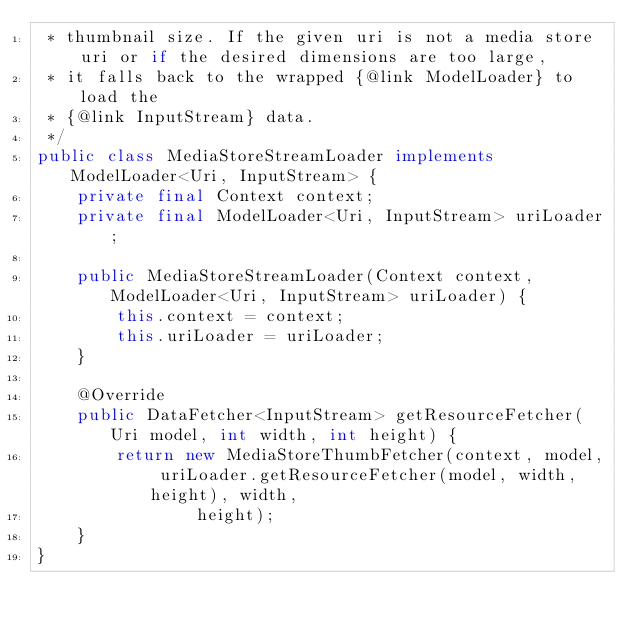<code> <loc_0><loc_0><loc_500><loc_500><_Java_> * thumbnail size. If the given uri is not a media store uri or if the desired dimensions are too large,
 * it falls back to the wrapped {@link ModelLoader} to load the
 * {@link InputStream} data.
 */
public class MediaStoreStreamLoader implements ModelLoader<Uri, InputStream> {
    private final Context context;
    private final ModelLoader<Uri, InputStream> uriLoader;

    public MediaStoreStreamLoader(Context context, ModelLoader<Uri, InputStream> uriLoader) {
        this.context = context;
        this.uriLoader = uriLoader;
    }

    @Override
    public DataFetcher<InputStream> getResourceFetcher(Uri model, int width, int height) {
        return new MediaStoreThumbFetcher(context, model, uriLoader.getResourceFetcher(model, width, height), width,
                height);
    }
}
</code> 